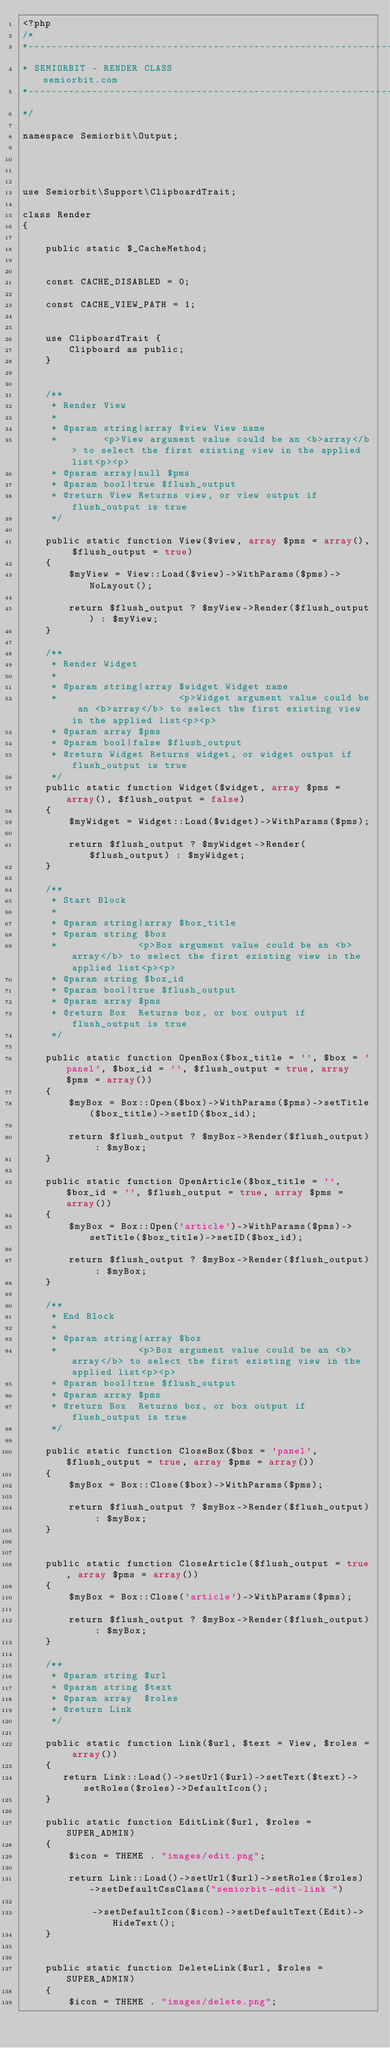Convert code to text. <code><loc_0><loc_0><loc_500><loc_500><_PHP_><?php
/*
*------------------------------------------------------------------------------------------------
* SEMIORBIT - RENDER CLASS   	    				 					 semiorbit.com
*------------------------------------------------------------------------------------------------
*/

namespace Semiorbit\Output;




use Semiorbit\Support\ClipboardTrait;

class Render
{

    public static $_CacheMethod;


    const CACHE_DISABLED = 0;

    const CACHE_VIEW_PATH = 1;


    use ClipboardTrait {
        Clipboard as public;
    }


    /**
     * Render View
     *
     * @param string|array $view View name
     *        <p>View argument value could be an <b>array</b> to select the first existing view in the applied list<p><p>
     * @param array|null $pms
     * @param bool|true $flush_output
     * @return View Returns view, or view output if flush_output is true
     */

    public static function View($view, array $pms = array(), $flush_output = true)
    {
        $myView = View::Load($view)->WithParams($pms)->NoLayout();

        return $flush_output ? $myView->Render($flush_output) : $myView;
    }

    /**
     * Render Widget
     *
     * @param string|array $widget Widget name
     *                     <p>Widget argument value could be an <b>array</b> to select the first existing view in the applied list<p><p>
     * @param array $pms
     * @param bool|false $flush_output
     * @return Widget Returns widget, or widget output if flush_output is true
     */
    public static function Widget($widget, array $pms = array(), $flush_output = false)
    {
        $myWidget = Widget::Load($widget)->WithParams($pms);

        return $flush_output ? $myWidget->Render($flush_output) : $myWidget;
    }

    /**
     * Start Block
     *
     * @param string|array $box_title
     * @param string $box
     *              <p>Box argument value could be an <b>array</b> to select the first existing view in the applied list<p><p>
     * @param string $box_id
     * @param bool|true $flush_output
     * @param array $pms
     * @return Box  Returns box, or box output if flush_output is true
     */

    public static function OpenBox($box_title = '', $box = 'panel', $box_id = '', $flush_output = true, array $pms = array())
    {
        $myBox = Box::Open($box)->WithParams($pms)->setTitle($box_title)->setID($box_id);

        return $flush_output ? $myBox->Render($flush_output) : $myBox;
    }

    public static function OpenArticle($box_title = '', $box_id = '', $flush_output = true, array $pms = array())
    {
        $myBox = Box::Open('article')->WithParams($pms)->setTitle($box_title)->setID($box_id);

        return $flush_output ? $myBox->Render($flush_output) : $myBox;
    }

    /**
     * End Block
     *
     * @param string|array $box
     *              <p>Box argument value could be an <b>array</b> to select the first existing view in the applied list<p><p>
     * @param bool|true $flush_output
     * @param array $pms
     * @return Box  Returns box, or box output if flush_output is true
     */

    public static function CloseBox($box = 'panel', $flush_output = true, array $pms = array())
    {
        $myBox = Box::Close($box)->WithParams($pms);

        return $flush_output ? $myBox->Render($flush_output) : $myBox;
    }


    public static function CloseArticle($flush_output = true, array $pms = array())
    {
        $myBox = Box::Close('article')->WithParams($pms);

        return $flush_output ? $myBox->Render($flush_output) : $myBox;
    }

    /**
     * @param string $url
     * @param string $text
     * @param array  $roles
     * @return Link
     */

    public static function Link($url, $text = View, $roles = array())
    {
       return Link::Load()->setUrl($url)->setText($text)->setRoles($roles)->DefaultIcon();
    }

    public static function EditLink($url, $roles = SUPER_ADMIN)
    {
        $icon = THEME . "images/edit.png";

        return Link::Load()->setUrl($url)->setRoles($roles)->setDefaultCssClass("semiorbit-edit-link ")

            ->setDefaultIcon($icon)->setDefaultText(Edit)->HideText();
    }


    public static function DeleteLink($url, $roles = SUPER_ADMIN)
    {
        $icon = THEME . "images/delete.png";
</code> 